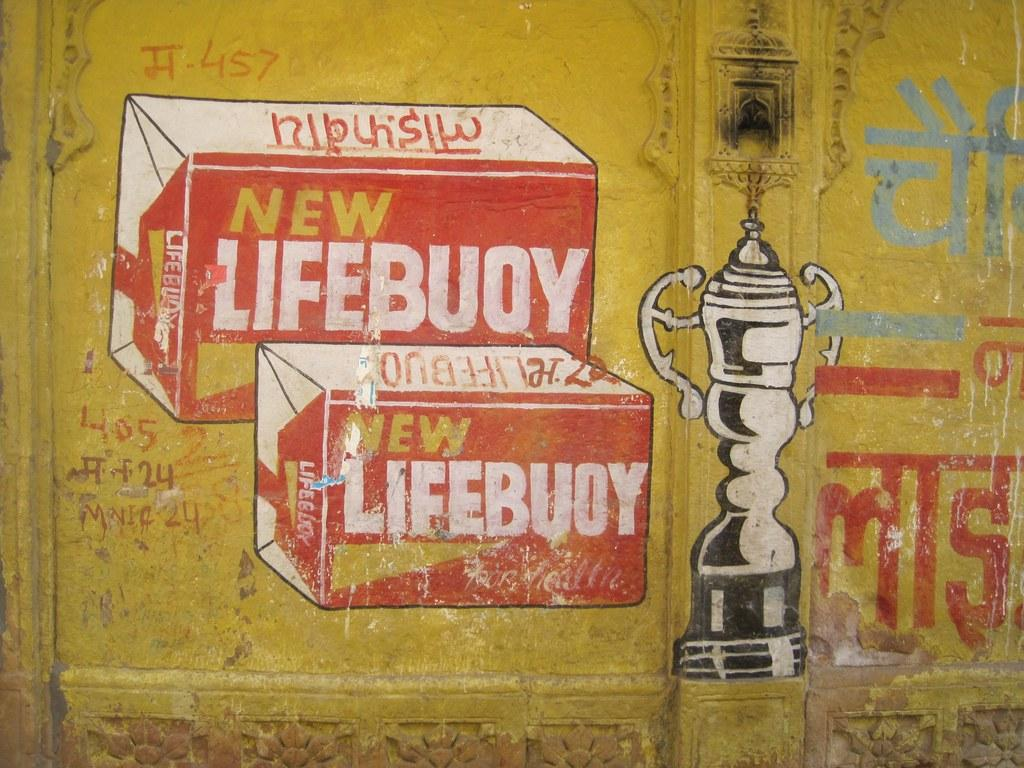What is depicted in the image? There is a painting in the image. What is the subject of the painting? The painting is of a soap. What color is the soap in the painting? The soap in the painting is red. Where is the painting located? The painting is on the wall. What type of toys can be seen in the painting? There are no toys present in the painting; it depicts a red soap. 